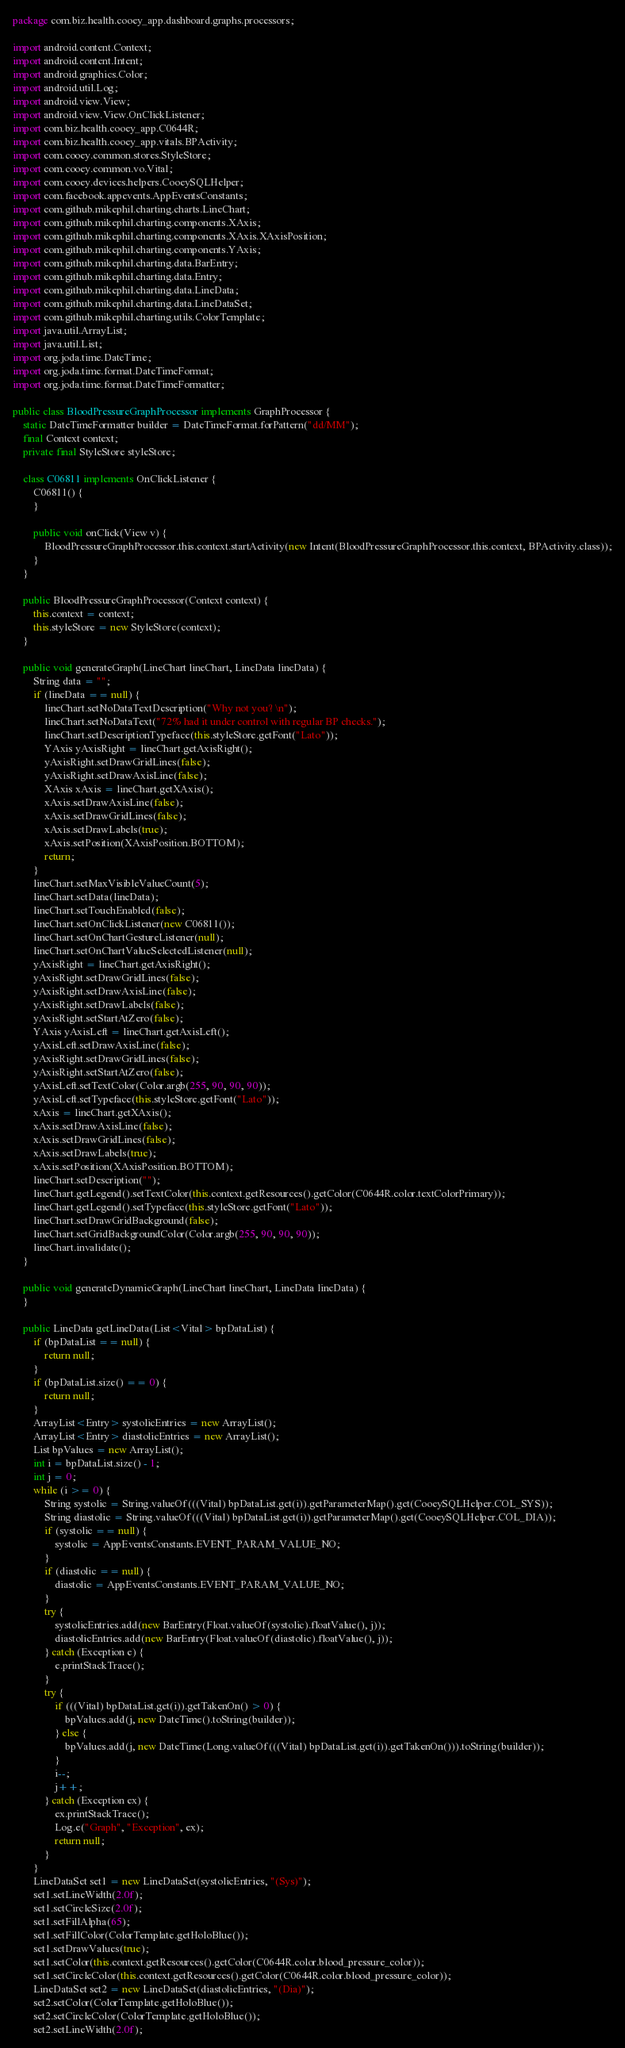Convert code to text. <code><loc_0><loc_0><loc_500><loc_500><_Java_>package com.biz.health.cooey_app.dashboard.graphs.processors;

import android.content.Context;
import android.content.Intent;
import android.graphics.Color;
import android.util.Log;
import android.view.View;
import android.view.View.OnClickListener;
import com.biz.health.cooey_app.C0644R;
import com.biz.health.cooey_app.vitals.BPActivity;
import com.cooey.common.stores.StyleStore;
import com.cooey.common.vo.Vital;
import com.cooey.devices.helpers.CooeySQLHelper;
import com.facebook.appevents.AppEventsConstants;
import com.github.mikephil.charting.charts.LineChart;
import com.github.mikephil.charting.components.XAxis;
import com.github.mikephil.charting.components.XAxis.XAxisPosition;
import com.github.mikephil.charting.components.YAxis;
import com.github.mikephil.charting.data.BarEntry;
import com.github.mikephil.charting.data.Entry;
import com.github.mikephil.charting.data.LineData;
import com.github.mikephil.charting.data.LineDataSet;
import com.github.mikephil.charting.utils.ColorTemplate;
import java.util.ArrayList;
import java.util.List;
import org.joda.time.DateTime;
import org.joda.time.format.DateTimeFormat;
import org.joda.time.format.DateTimeFormatter;

public class BloodPressureGraphProcessor implements GraphProcessor {
    static DateTimeFormatter builder = DateTimeFormat.forPattern("dd/MM");
    final Context context;
    private final StyleStore styleStore;

    class C06811 implements OnClickListener {
        C06811() {
        }

        public void onClick(View v) {
            BloodPressureGraphProcessor.this.context.startActivity(new Intent(BloodPressureGraphProcessor.this.context, BPActivity.class));
        }
    }

    public BloodPressureGraphProcessor(Context context) {
        this.context = context;
        this.styleStore = new StyleStore(context);
    }

    public void generateGraph(LineChart lineChart, LineData lineData) {
        String data = "";
        if (lineData == null) {
            lineChart.setNoDataTextDescription("Why not you? \n");
            lineChart.setNoDataText("72% had it under control with regular BP checks.");
            lineChart.setDescriptionTypeface(this.styleStore.getFont("Lato"));
            YAxis yAxisRight = lineChart.getAxisRight();
            yAxisRight.setDrawGridLines(false);
            yAxisRight.setDrawAxisLine(false);
            XAxis xAxis = lineChart.getXAxis();
            xAxis.setDrawAxisLine(false);
            xAxis.setDrawGridLines(false);
            xAxis.setDrawLabels(true);
            xAxis.setPosition(XAxisPosition.BOTTOM);
            return;
        }
        lineChart.setMaxVisibleValueCount(5);
        lineChart.setData(lineData);
        lineChart.setTouchEnabled(false);
        lineChart.setOnClickListener(new C06811());
        lineChart.setOnChartGestureListener(null);
        lineChart.setOnChartValueSelectedListener(null);
        yAxisRight = lineChart.getAxisRight();
        yAxisRight.setDrawGridLines(false);
        yAxisRight.setDrawAxisLine(false);
        yAxisRight.setDrawLabels(false);
        yAxisRight.setStartAtZero(false);
        YAxis yAxisLeft = lineChart.getAxisLeft();
        yAxisLeft.setDrawAxisLine(false);
        yAxisRight.setDrawGridLines(false);
        yAxisRight.setStartAtZero(false);
        yAxisLeft.setTextColor(Color.argb(255, 90, 90, 90));
        yAxisLeft.setTypeface(this.styleStore.getFont("Lato"));
        xAxis = lineChart.getXAxis();
        xAxis.setDrawAxisLine(false);
        xAxis.setDrawGridLines(false);
        xAxis.setDrawLabels(true);
        xAxis.setPosition(XAxisPosition.BOTTOM);
        lineChart.setDescription("");
        lineChart.getLegend().setTextColor(this.context.getResources().getColor(C0644R.color.textColorPrimary));
        lineChart.getLegend().setTypeface(this.styleStore.getFont("Lato"));
        lineChart.setDrawGridBackground(false);
        lineChart.setGridBackgroundColor(Color.argb(255, 90, 90, 90));
        lineChart.invalidate();
    }

    public void generateDynamicGraph(LineChart lineChart, LineData lineData) {
    }

    public LineData getLineData(List<Vital> bpDataList) {
        if (bpDataList == null) {
            return null;
        }
        if (bpDataList.size() == 0) {
            return null;
        }
        ArrayList<Entry> systolicEntries = new ArrayList();
        ArrayList<Entry> diastolicEntries = new ArrayList();
        List bpValues = new ArrayList();
        int i = bpDataList.size() - 1;
        int j = 0;
        while (i >= 0) {
            String systolic = String.valueOf(((Vital) bpDataList.get(i)).getParameterMap().get(CooeySQLHelper.COL_SYS));
            String diastolic = String.valueOf(((Vital) bpDataList.get(i)).getParameterMap().get(CooeySQLHelper.COL_DIA));
            if (systolic == null) {
                systolic = AppEventsConstants.EVENT_PARAM_VALUE_NO;
            }
            if (diastolic == null) {
                diastolic = AppEventsConstants.EVENT_PARAM_VALUE_NO;
            }
            try {
                systolicEntries.add(new BarEntry(Float.valueOf(systolic).floatValue(), j));
                diastolicEntries.add(new BarEntry(Float.valueOf(diastolic).floatValue(), j));
            } catch (Exception e) {
                e.printStackTrace();
            }
            try {
                if (((Vital) bpDataList.get(i)).getTakenOn() > 0) {
                    bpValues.add(j, new DateTime().toString(builder));
                } else {
                    bpValues.add(j, new DateTime(Long.valueOf(((Vital) bpDataList.get(i)).getTakenOn())).toString(builder));
                }
                i--;
                j++;
            } catch (Exception ex) {
                ex.printStackTrace();
                Log.e("Graph", "Exception", ex);
                return null;
            }
        }
        LineDataSet set1 = new LineDataSet(systolicEntries, "(Sys)");
        set1.setLineWidth(2.0f);
        set1.setCircleSize(2.0f);
        set1.setFillAlpha(65);
        set1.setFillColor(ColorTemplate.getHoloBlue());
        set1.setDrawValues(true);
        set1.setColor(this.context.getResources().getColor(C0644R.color.blood_pressure_color));
        set1.setCircleColor(this.context.getResources().getColor(C0644R.color.blood_pressure_color));
        LineDataSet set2 = new LineDataSet(diastolicEntries, "(Dia)");
        set2.setColor(ColorTemplate.getHoloBlue());
        set2.setCircleColor(ColorTemplate.getHoloBlue());
        set2.setLineWidth(2.0f);</code> 